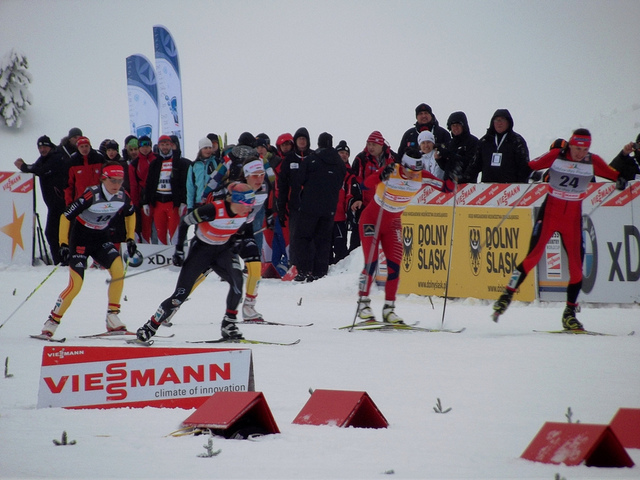What can you tell about the level of competition in this event? Given the presence of race numbers and professional-looking gear, this appears to be a high-level competitive event, possibly a regional or international competition. Can you guess which part of the race this might be? Based on the racers' proximity to each other and the intensity of their posture, it's likely the beginning or middle of the race where athletes are jockeying for position before the final stretch. 